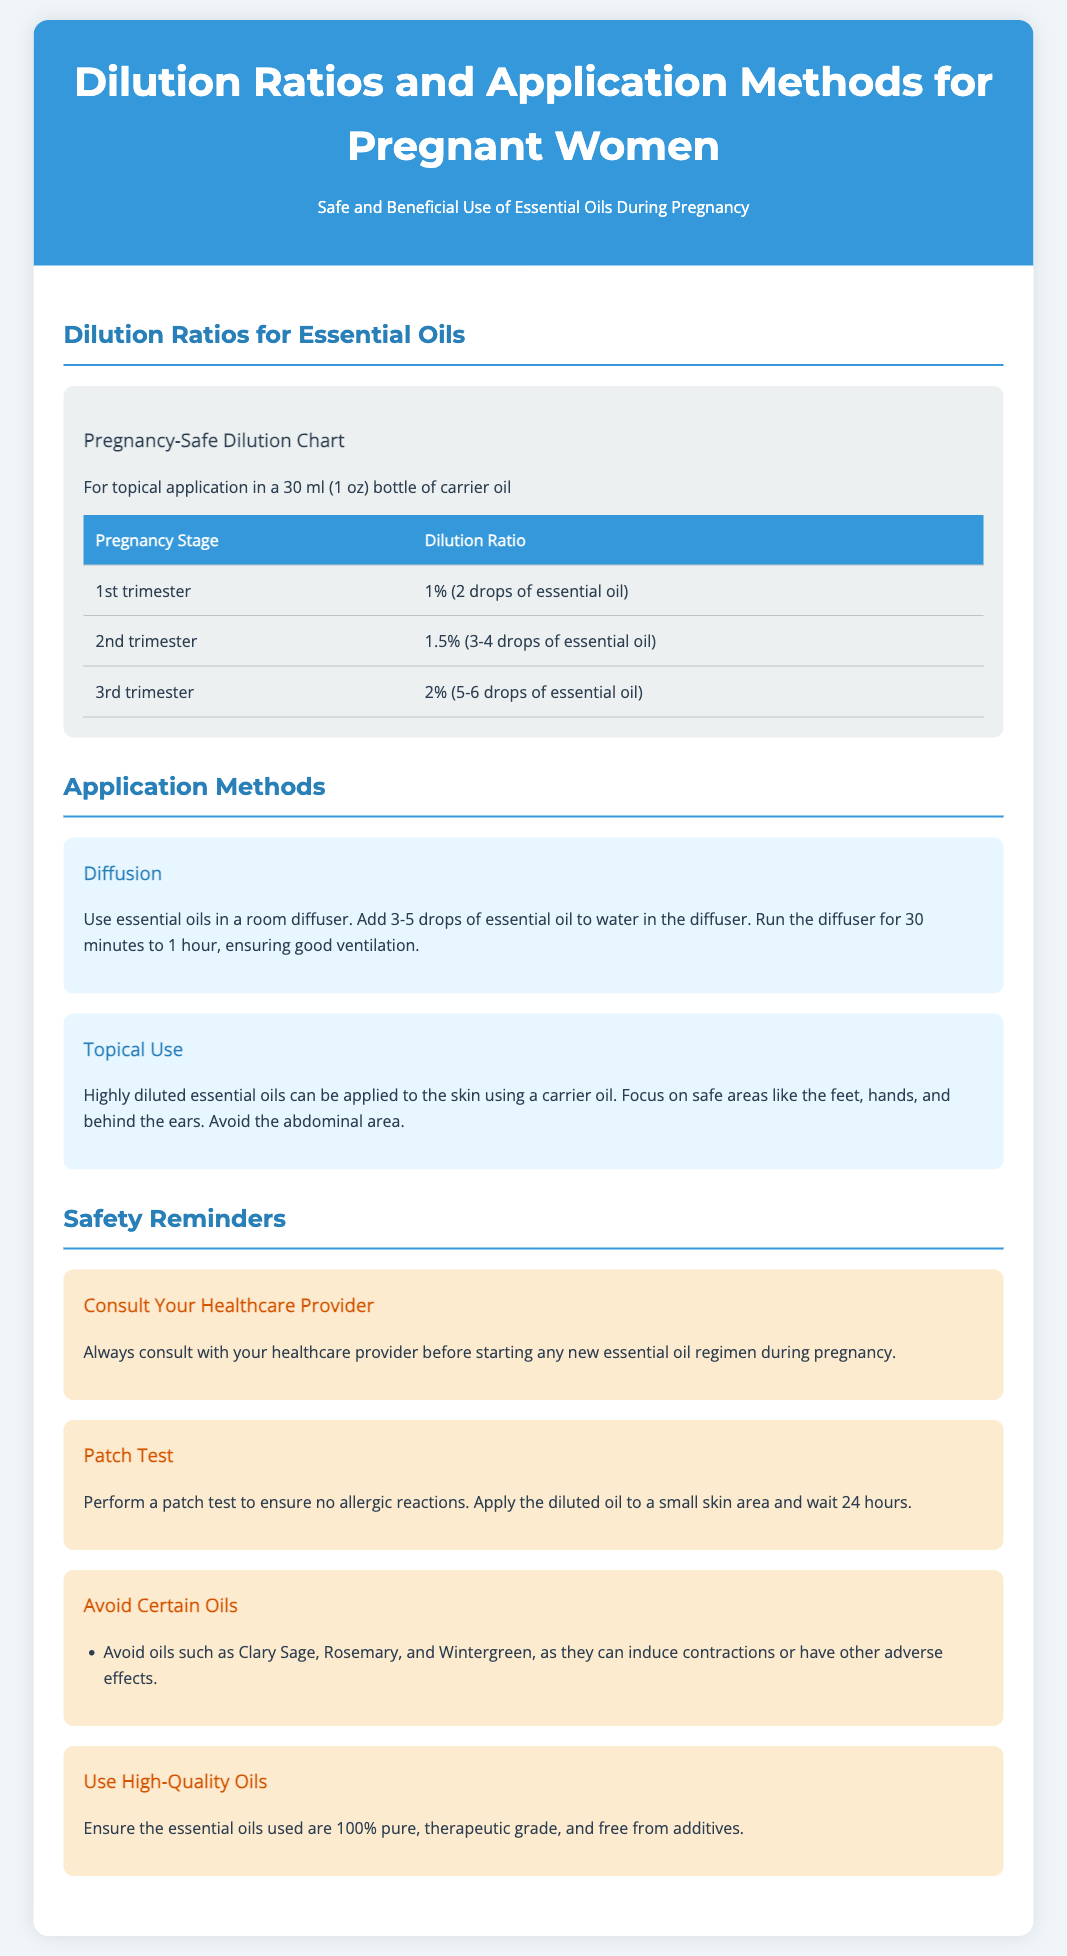What is the dilution ratio for the 1st trimester? The dilution ratio for the 1st trimester is found in the pregnancy safe dilution chart mentioned in the document.
Answer: 1% (2 drops of essential oil) What essential oils should be avoided during pregnancy? The document lists specific oils to avoid due to their potential adverse effects, found in the safety reminders section.
Answer: Clary Sage, Rosemary, Wintergreen How long should a diffuser be run with essential oils? The recommended time for running the diffuser is specified in the application methods section.
Answer: 30 minutes to 1 hour What is the highest dilution ratio recommended during the 3rd trimester? The chart provides dilution ratios for each trimester, including the 3rd trimester.
Answer: 2% (5-6 drops of essential oil) What application method uses a carrier oil? The section on application methods explains different ways essential oils can be used, specifying the method that involves a carrier oil.
Answer: Topical Use What should be performed before applying diluted oil to the skin? A precautionary measure is mentioned in the safety reminders, indicating a test that should be done prior to application.
Answer: Patch Test How many drops of essential oil should be added for a 1.5% dilution? The dilution chart provides information on the number of drops for different dilution ratios, specifically for the 2nd trimester.
Answer: 3-4 drops What type of oils should be used during pregnancy? The safety reminders specify the quality of oils that should be used, highlighting their purity and grade.
Answer: 100% pure, therapeutic grade What is the purpose of consulting a healthcare provider? The document advises this in the safety reminders and talks about its importance before using essential oils.
Answer: Safety before starting any new essential oil regimen 